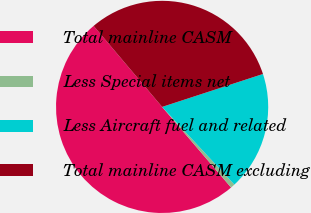Convert chart to OTSL. <chart><loc_0><loc_0><loc_500><loc_500><pie_chart><fcel>Total mainline CASM<fcel>Less Special items net<fcel>Less Aircraft fuel and related<fcel>Total mainline CASM excluding<nl><fcel>50.09%<fcel>0.66%<fcel>18.1%<fcel>31.15%<nl></chart> 